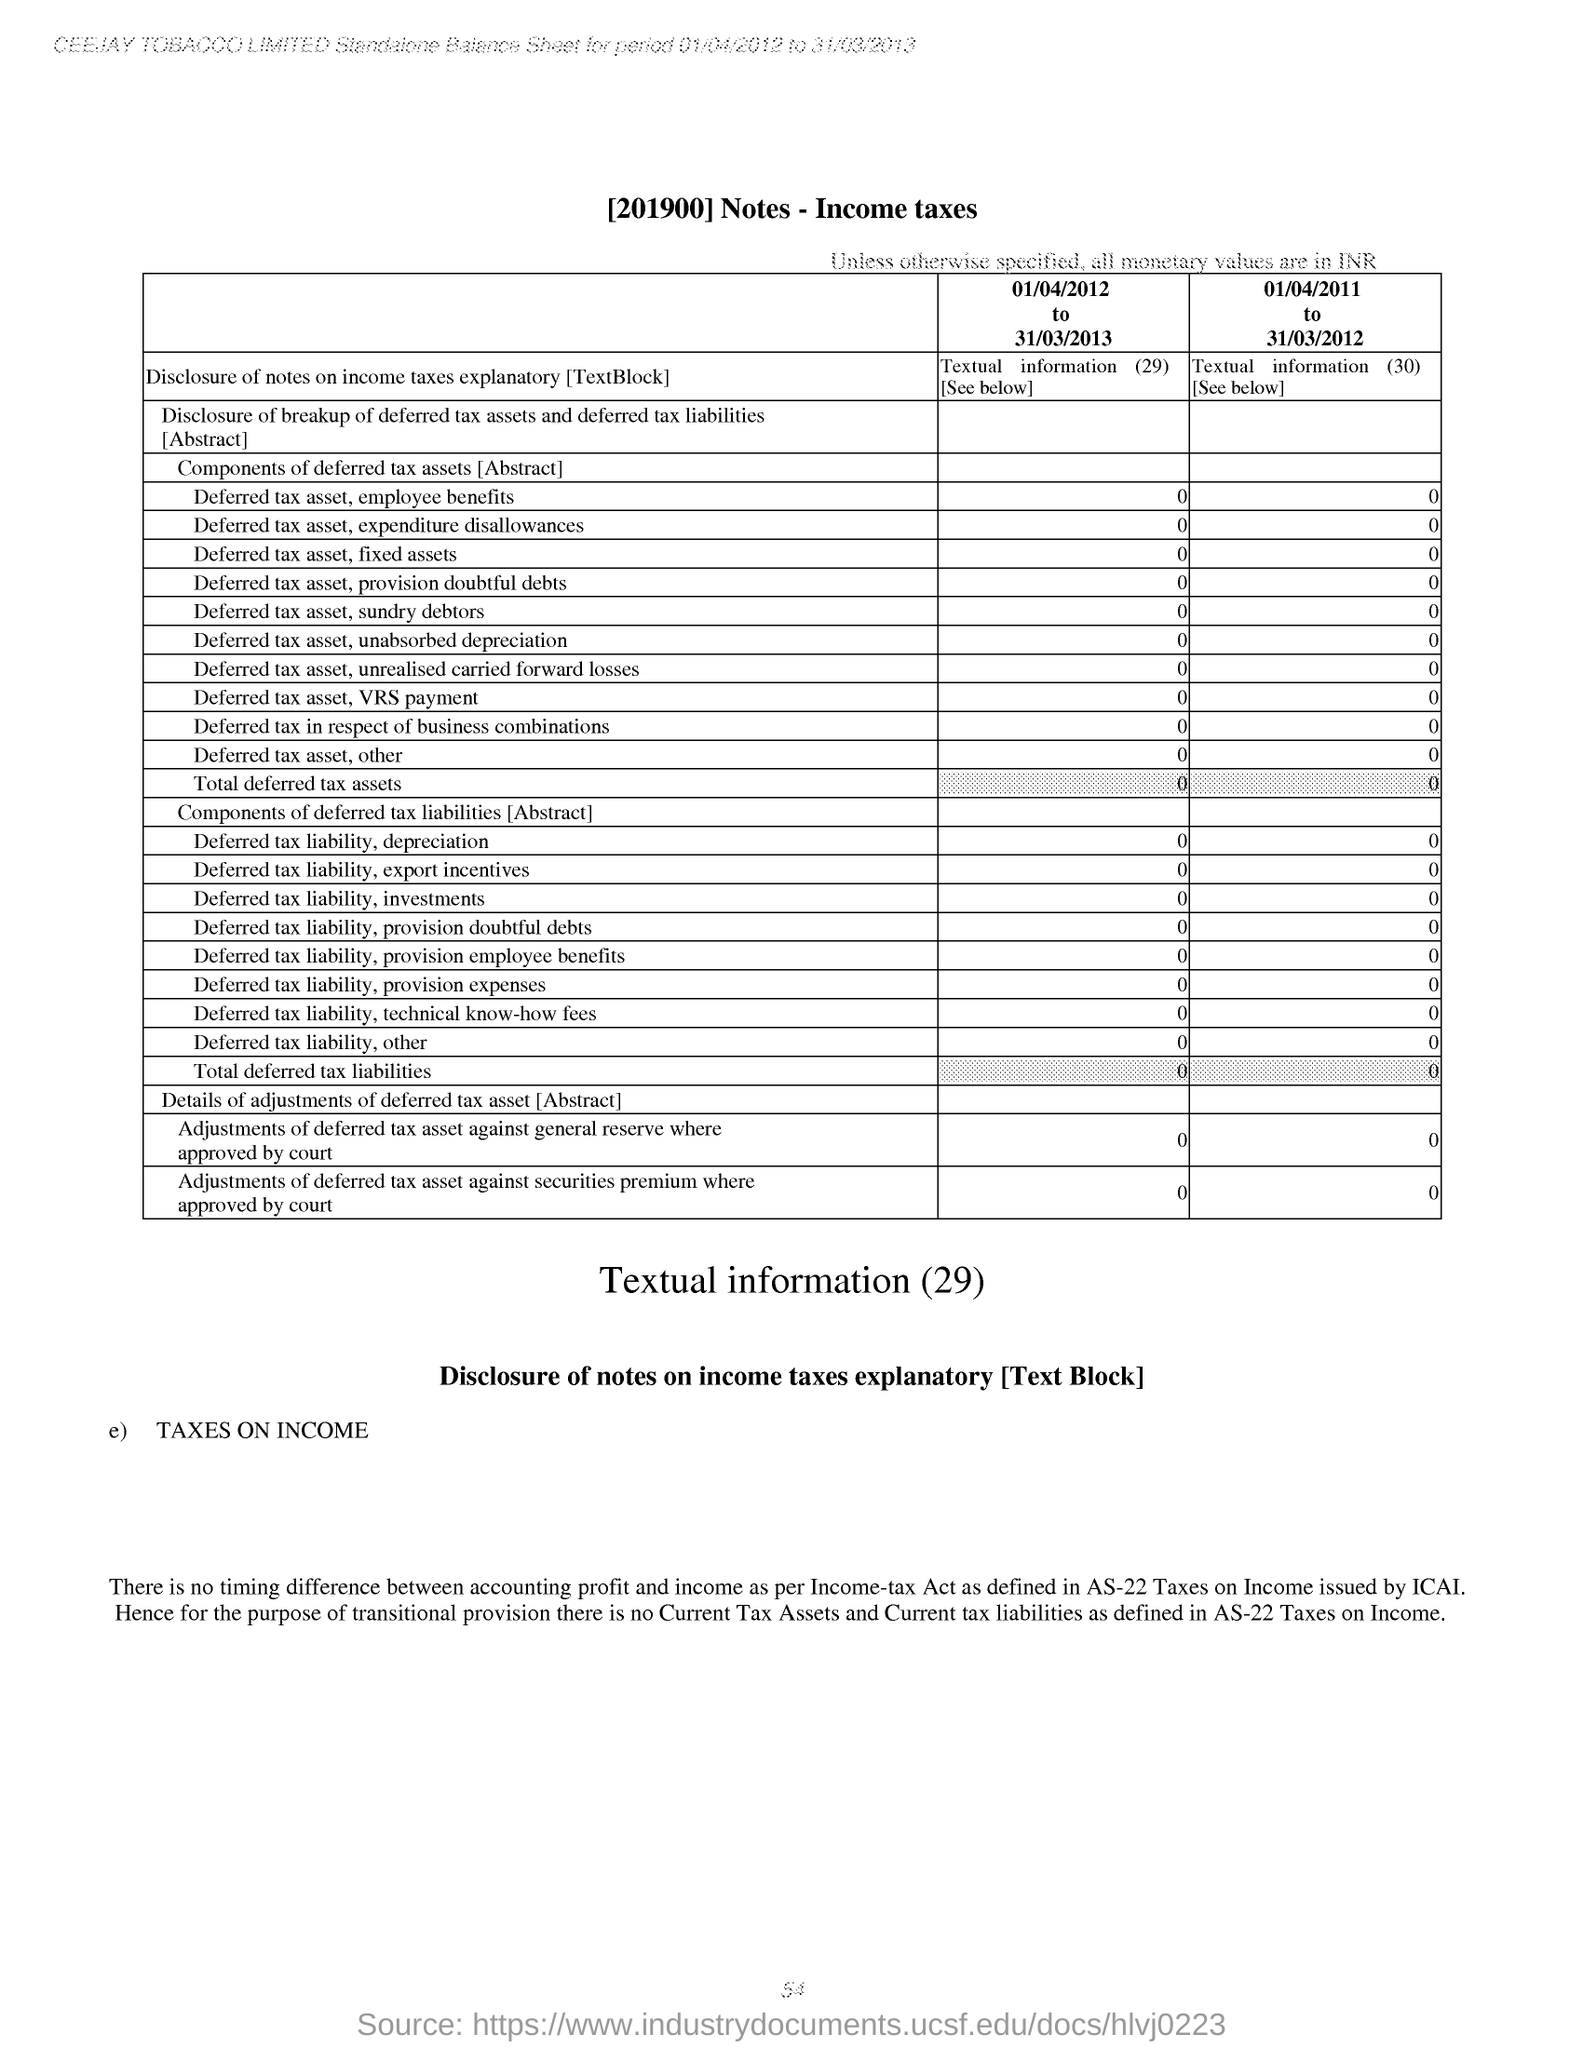Give some essential details in this illustration. What is a deferred tax asset, and what is the process of provisioning for doubtful debts from April 1, 2012 to March 31, 2013? For the period of April 1, 2012 to March 31, 2013, the deferred tax asset and expenditure disallowances were as follows. What is the deferred tax asset and employee benefits for the period of 01/04/2012 to 31/03/2013? The total deferred tax assets for the period of January 4, 2012 to March 31, 2013 is [objective information]. The deferred tax asset and other amount for the period of April 1, 2012 to March 31, 2013 was [amount]. 